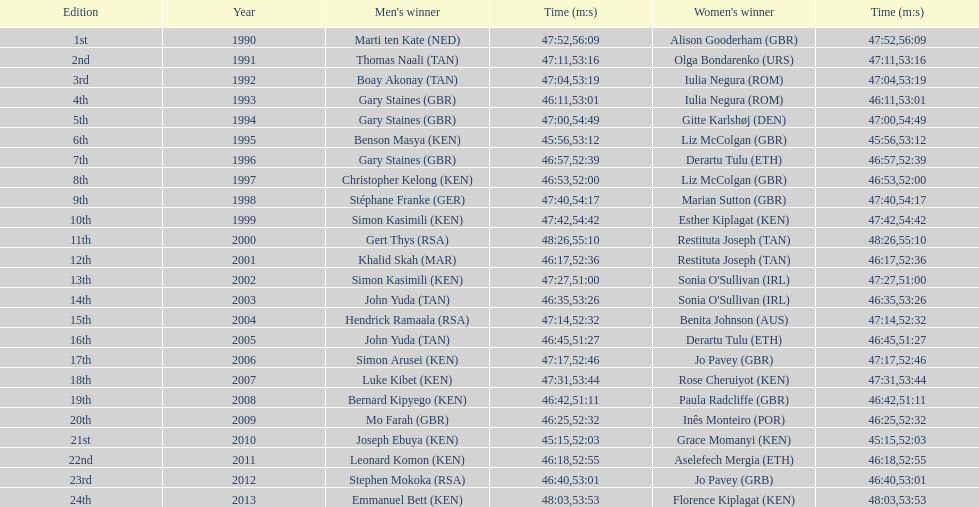Parse the table in full. {'header': ['Edition', 'Year', "Men's winner", 'Time (m:s)', "Women's winner", 'Time (m:s)'], 'rows': [['1st', '1990', 'Marti ten Kate\xa0(NED)', '47:52', 'Alison Gooderham\xa0(GBR)', '56:09'], ['2nd', '1991', 'Thomas Naali\xa0(TAN)', '47:11', 'Olga Bondarenko\xa0(URS)', '53:16'], ['3rd', '1992', 'Boay Akonay\xa0(TAN)', '47:04', 'Iulia Negura\xa0(ROM)', '53:19'], ['4th', '1993', 'Gary Staines\xa0(GBR)', '46:11', 'Iulia Negura\xa0(ROM)', '53:01'], ['5th', '1994', 'Gary Staines\xa0(GBR)', '47:00', 'Gitte Karlshøj\xa0(DEN)', '54:49'], ['6th', '1995', 'Benson Masya\xa0(KEN)', '45:56', 'Liz McColgan\xa0(GBR)', '53:12'], ['7th', '1996', 'Gary Staines\xa0(GBR)', '46:57', 'Derartu Tulu\xa0(ETH)', '52:39'], ['8th', '1997', 'Christopher Kelong\xa0(KEN)', '46:53', 'Liz McColgan\xa0(GBR)', '52:00'], ['9th', '1998', 'Stéphane Franke\xa0(GER)', '47:40', 'Marian Sutton\xa0(GBR)', '54:17'], ['10th', '1999', 'Simon Kasimili\xa0(KEN)', '47:42', 'Esther Kiplagat\xa0(KEN)', '54:42'], ['11th', '2000', 'Gert Thys\xa0(RSA)', '48:26', 'Restituta Joseph\xa0(TAN)', '55:10'], ['12th', '2001', 'Khalid Skah\xa0(MAR)', '46:17', 'Restituta Joseph\xa0(TAN)', '52:36'], ['13th', '2002', 'Simon Kasimili\xa0(KEN)', '47:27', "Sonia O'Sullivan\xa0(IRL)", '51:00'], ['14th', '2003', 'John Yuda\xa0(TAN)', '46:35', "Sonia O'Sullivan\xa0(IRL)", '53:26'], ['15th', '2004', 'Hendrick Ramaala\xa0(RSA)', '47:14', 'Benita Johnson\xa0(AUS)', '52:32'], ['16th', '2005', 'John Yuda\xa0(TAN)', '46:45', 'Derartu Tulu\xa0(ETH)', '51:27'], ['17th', '2006', 'Simon Arusei\xa0(KEN)', '47:17', 'Jo Pavey\xa0(GBR)', '52:46'], ['18th', '2007', 'Luke Kibet\xa0(KEN)', '47:31', 'Rose Cheruiyot\xa0(KEN)', '53:44'], ['19th', '2008', 'Bernard Kipyego\xa0(KEN)', '46:42', 'Paula Radcliffe\xa0(GBR)', '51:11'], ['20th', '2009', 'Mo Farah\xa0(GBR)', '46:25', 'Inês Monteiro\xa0(POR)', '52:32'], ['21st', '2010', 'Joseph Ebuya\xa0(KEN)', '45:15', 'Grace Momanyi\xa0(KEN)', '52:03'], ['22nd', '2011', 'Leonard Komon\xa0(KEN)', '46:18', 'Aselefech Mergia\xa0(ETH)', '52:55'], ['23rd', '2012', 'Stephen Mokoka\xa0(RSA)', '46:40', 'Jo Pavey\xa0(GRB)', '53:01'], ['24th', '2013', 'Emmanuel Bett\xa0(KEN)', '48:03', 'Florence Kiplagat\xa0(KEN)', '53:53']]} In how many instances did men's winners finish the race with a time below 46:58? 12. 